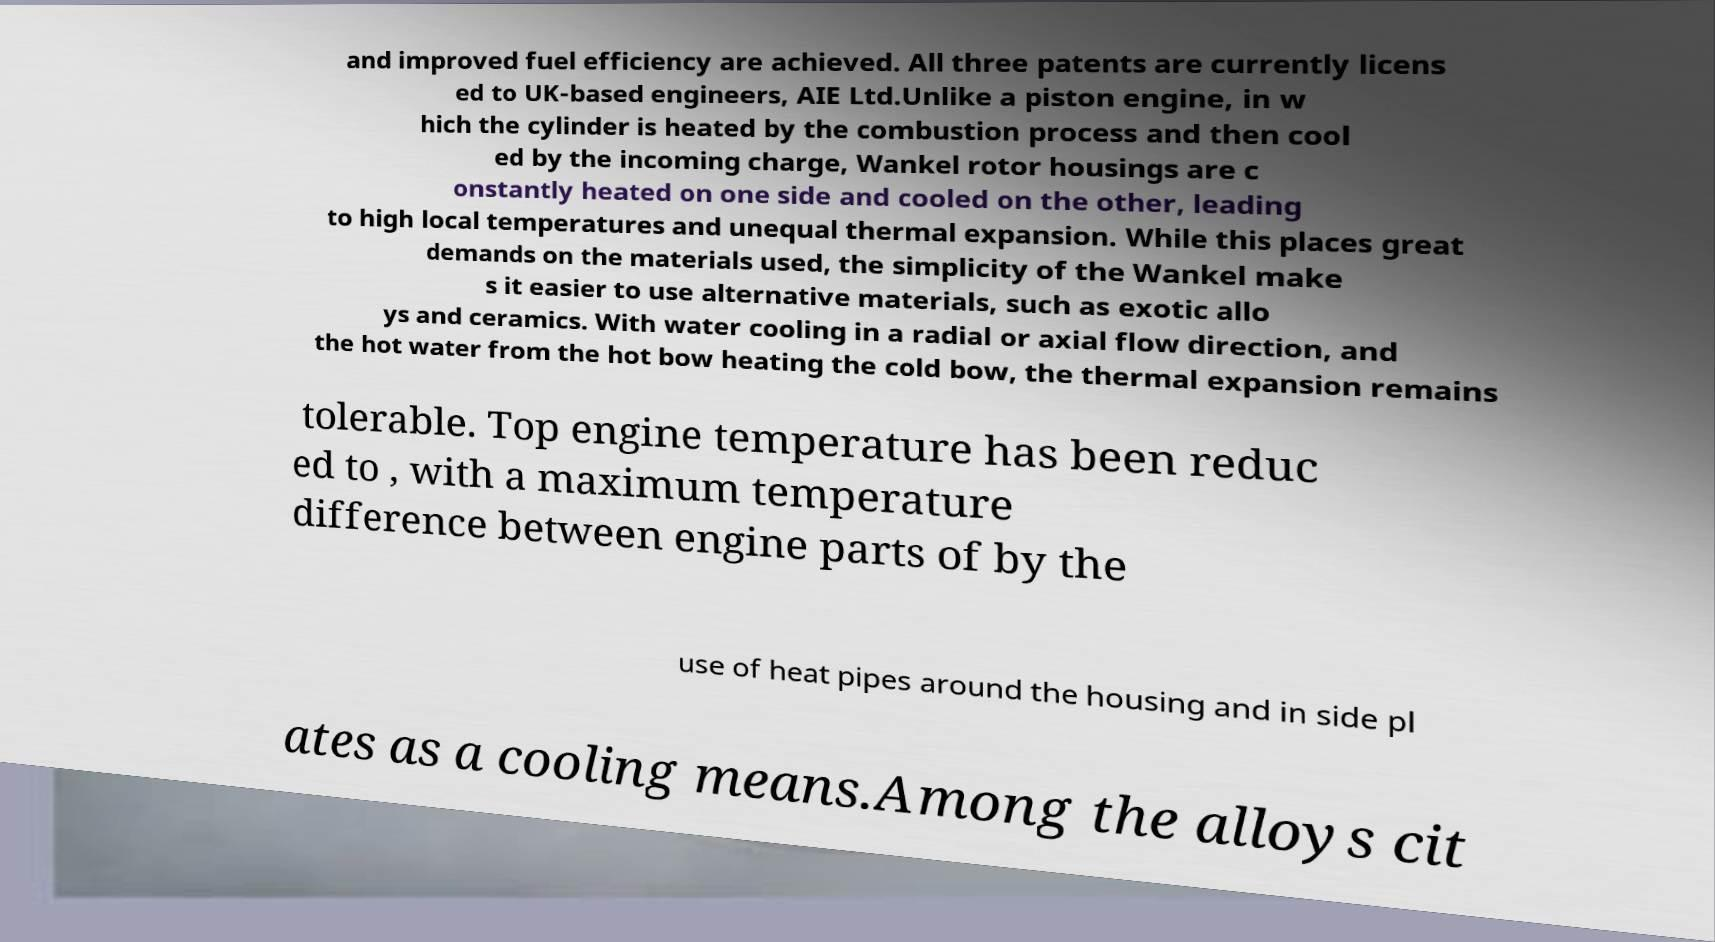Can you accurately transcribe the text from the provided image for me? and improved fuel efficiency are achieved. All three patents are currently licens ed to UK-based engineers, AIE Ltd.Unlike a piston engine, in w hich the cylinder is heated by the combustion process and then cool ed by the incoming charge, Wankel rotor housings are c onstantly heated on one side and cooled on the other, leading to high local temperatures and unequal thermal expansion. While this places great demands on the materials used, the simplicity of the Wankel make s it easier to use alternative materials, such as exotic allo ys and ceramics. With water cooling in a radial or axial flow direction, and the hot water from the hot bow heating the cold bow, the thermal expansion remains tolerable. Top engine temperature has been reduc ed to , with a maximum temperature difference between engine parts of by the use of heat pipes around the housing and in side pl ates as a cooling means.Among the alloys cit 